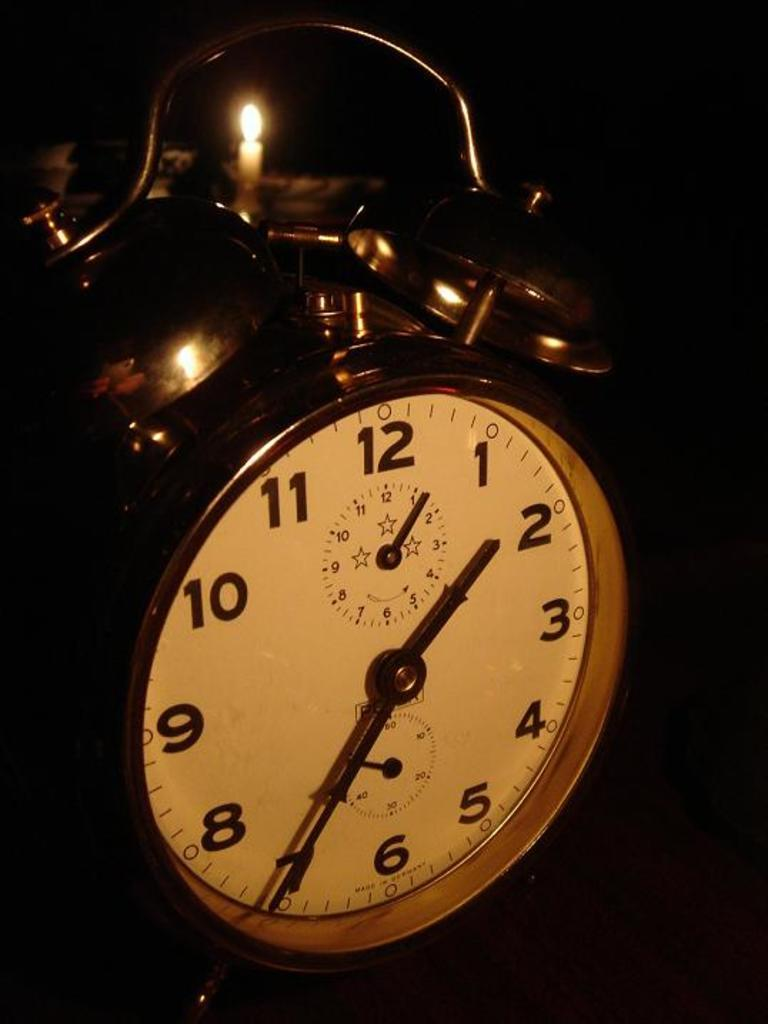<image>
Present a compact description of the photo's key features. The face of an alarm clock shows the time as 1:35. 